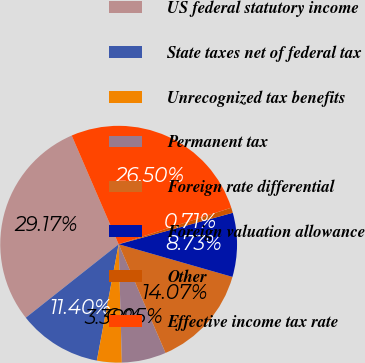<chart> <loc_0><loc_0><loc_500><loc_500><pie_chart><fcel>US federal statutory income<fcel>State taxes net of federal tax<fcel>Unrecognized tax benefits<fcel>Permanent tax<fcel>Foreign rate differential<fcel>Foreign valuation allowance<fcel>Other<fcel>Effective income tax rate<nl><fcel>29.17%<fcel>11.4%<fcel>3.38%<fcel>6.05%<fcel>14.07%<fcel>8.73%<fcel>0.71%<fcel>26.5%<nl></chart> 